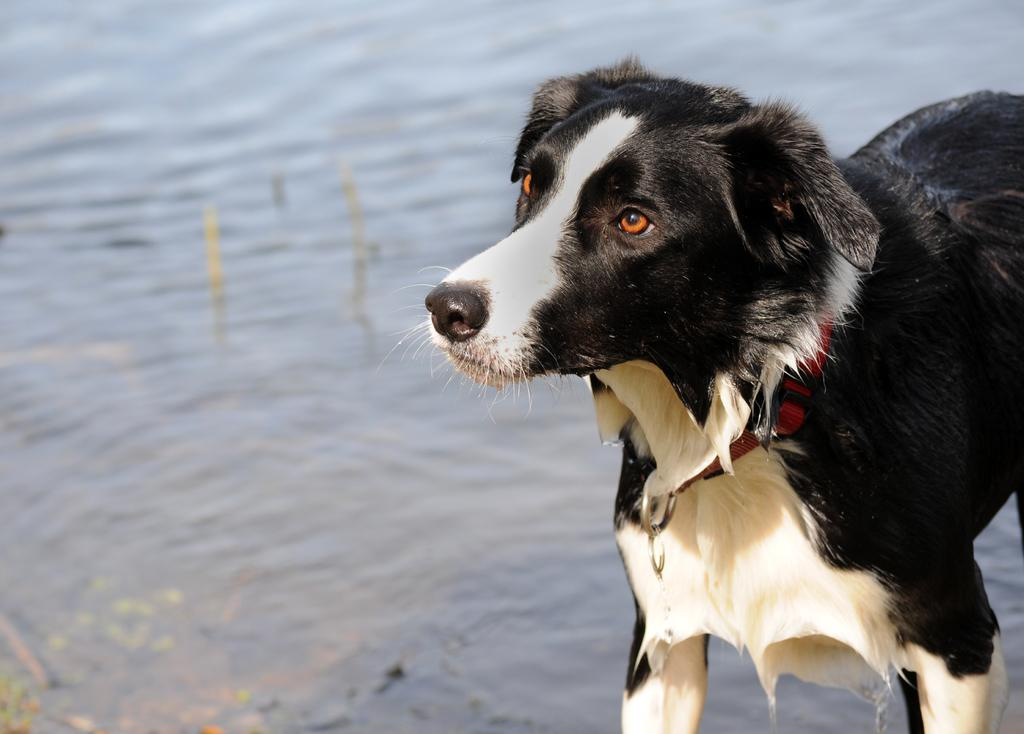What animal is present in the image? There is a dog in the image. What is the dog doing in the image? The dog is standing in the image. On which side of the dog is located in the image? The dog is on the right side of the image. What can be seen behind the dog in the image? There is water visible behind the dog. What type of substance is the dog using to stitch its pocket in the image? There is no indication in the image that the dog is using any substance to stitch a pocket, as dogs do not have pockets and cannot perform such tasks. 